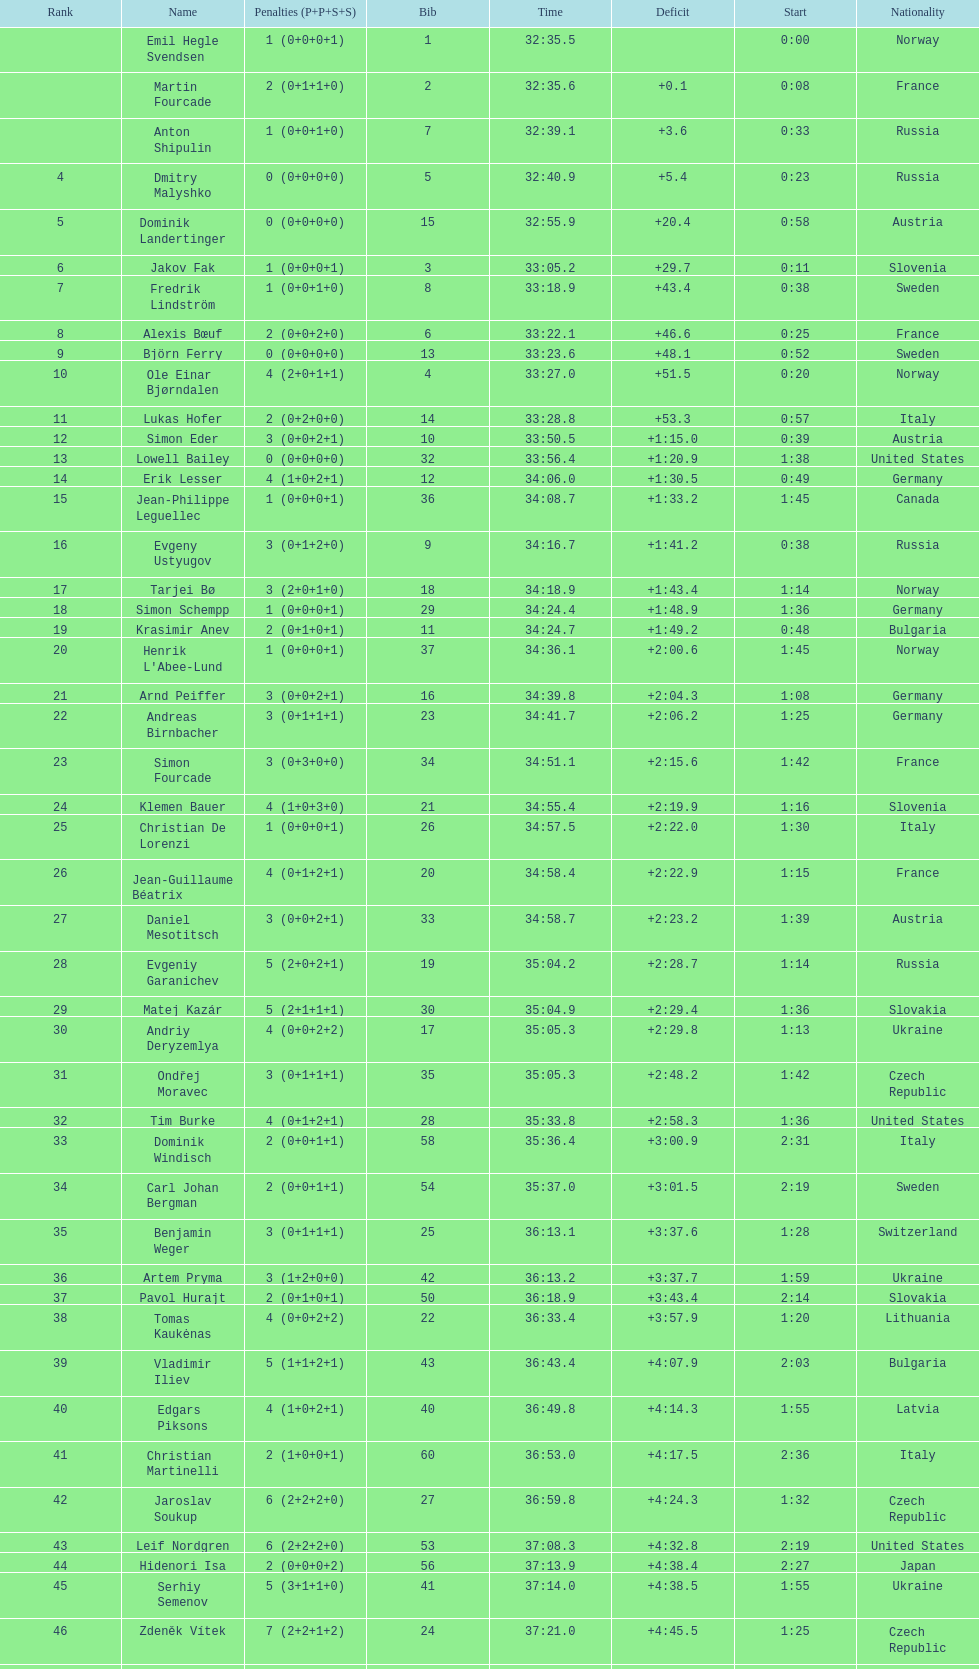What were the aggregate number of "ties" (people who concluded with the exact same time?) 2. 